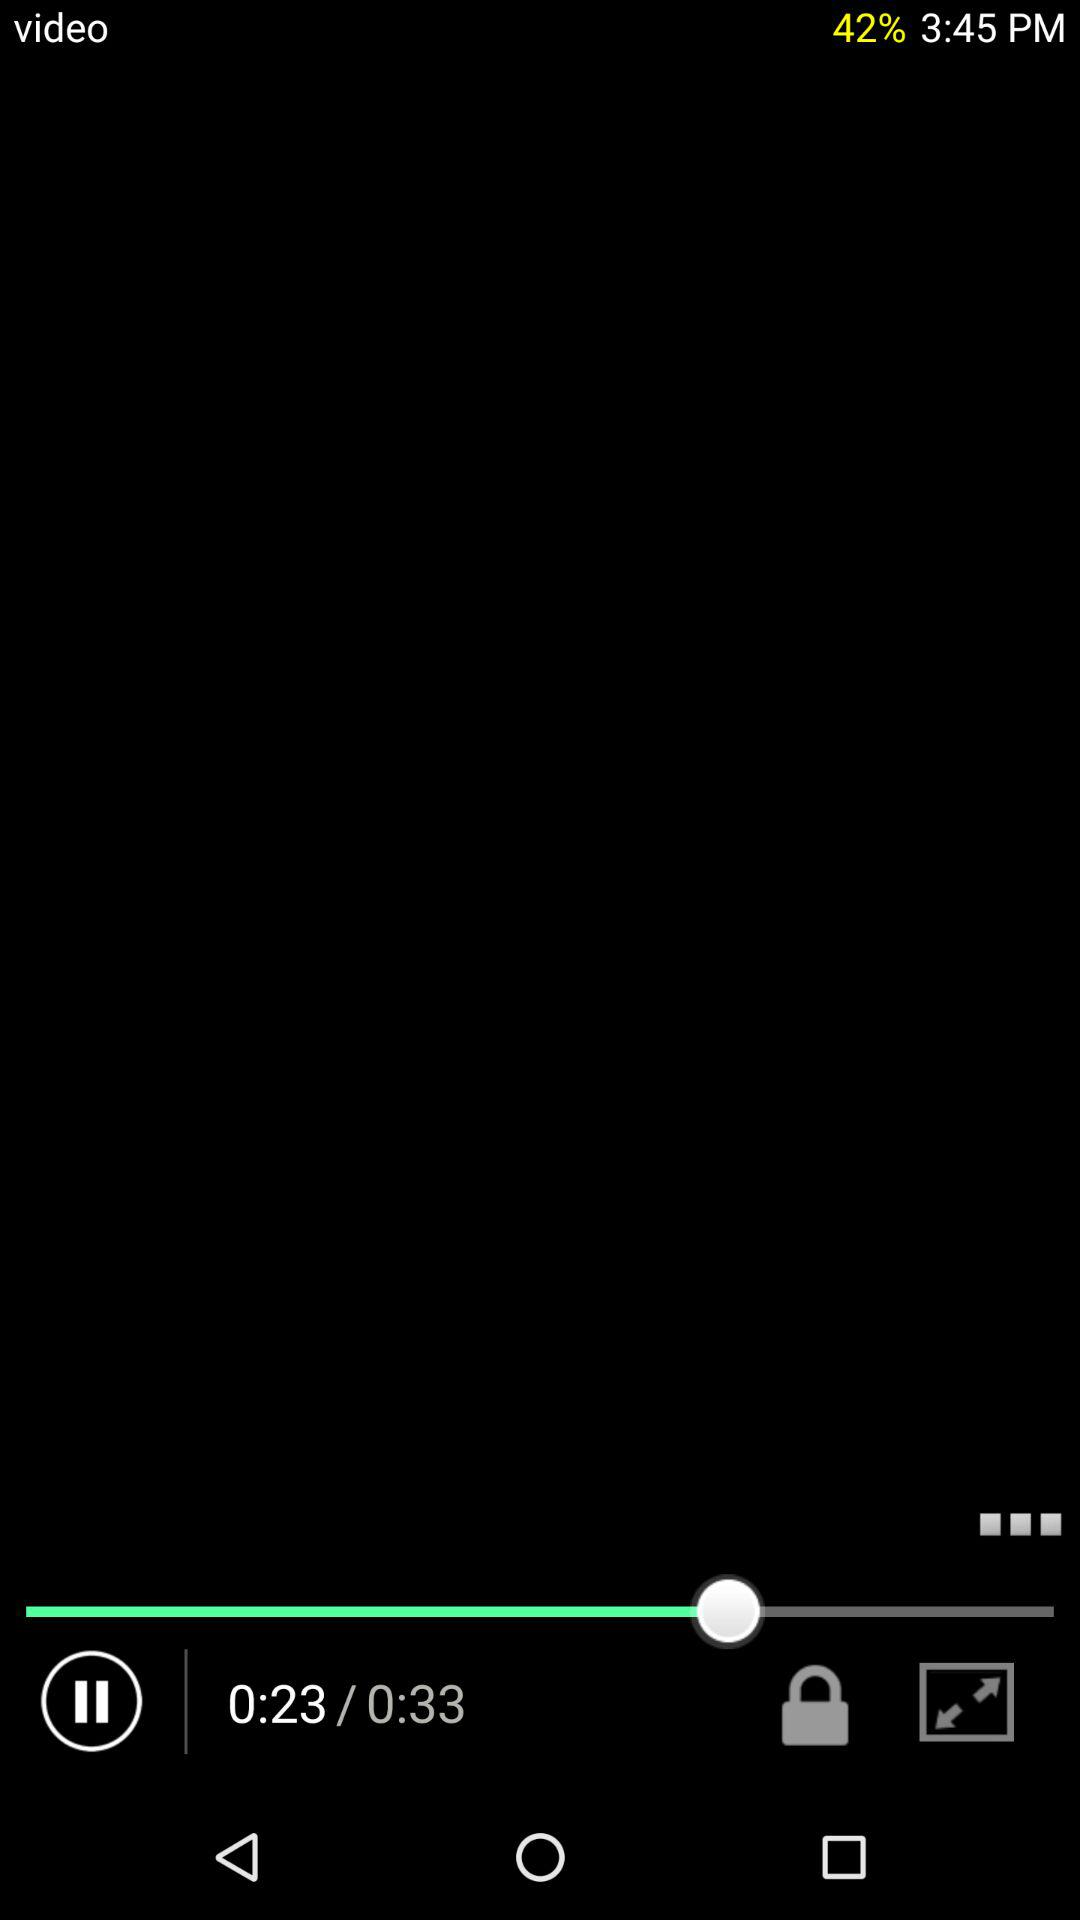How many videos are in the playlist?
When the provided information is insufficient, respond with <no answer>. <no answer> 